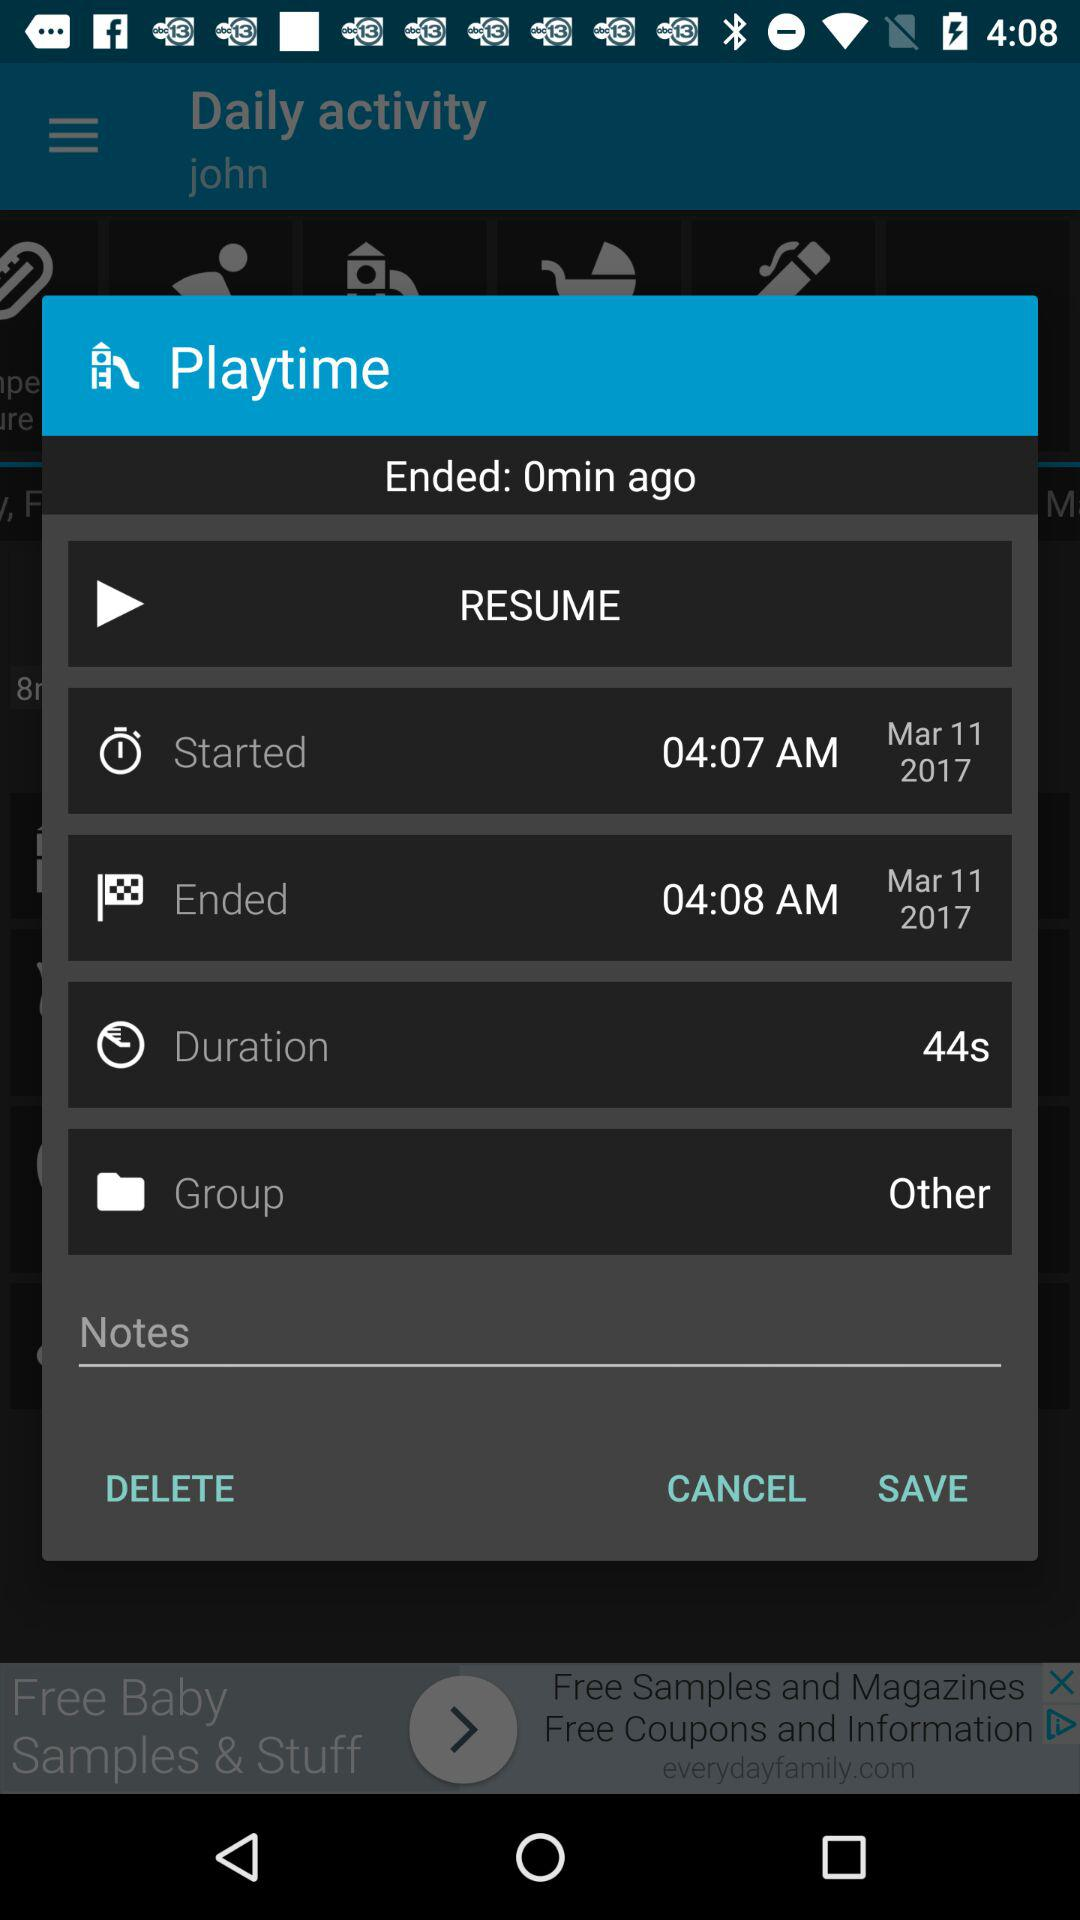What is the ending time? The ending time is 04:08 a.m. 